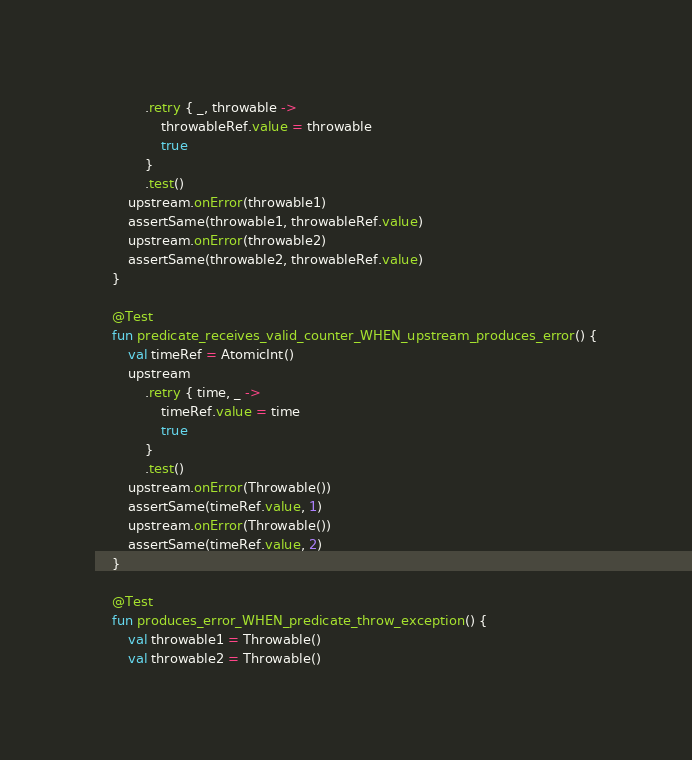Convert code to text. <code><loc_0><loc_0><loc_500><loc_500><_Kotlin_>            .retry { _, throwable ->
                throwableRef.value = throwable
                true
            }
            .test()
        upstream.onError(throwable1)
        assertSame(throwable1, throwableRef.value)
        upstream.onError(throwable2)
        assertSame(throwable2, throwableRef.value)
    }

    @Test
    fun predicate_receives_valid_counter_WHEN_upstream_produces_error() {
        val timeRef = AtomicInt()
        upstream
            .retry { time, _ ->
                timeRef.value = time
                true
            }
            .test()
        upstream.onError(Throwable())
        assertSame(timeRef.value, 1)
        upstream.onError(Throwable())
        assertSame(timeRef.value, 2)
    }

    @Test
    fun produces_error_WHEN_predicate_throw_exception() {
        val throwable1 = Throwable()
        val throwable2 = Throwable()</code> 